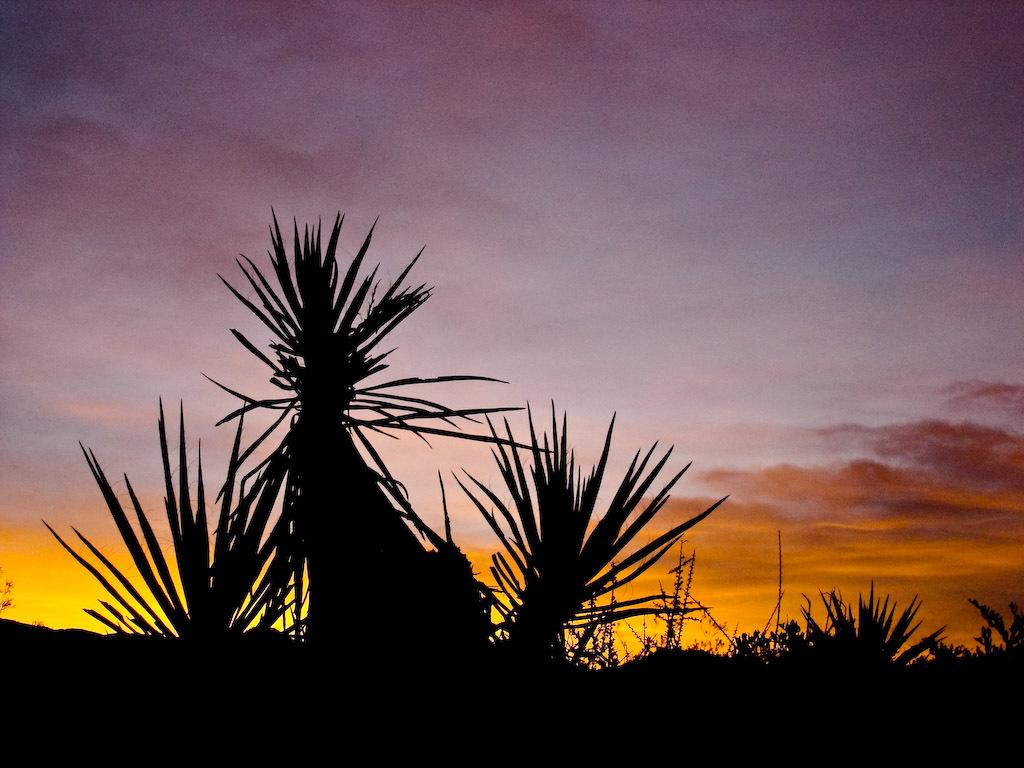What type of vegetation is at the bottom of the image? There are trees at the bottom of the image. What color are the trees? The trees are in black color. What can be seen in the background of the image? There is a sky visible in the background of the image. What colors are present in the sky? The sky has a purple and yellow color. What type of liquid can be seen dripping from the trees in the image? There is no liquid visible in the image. 